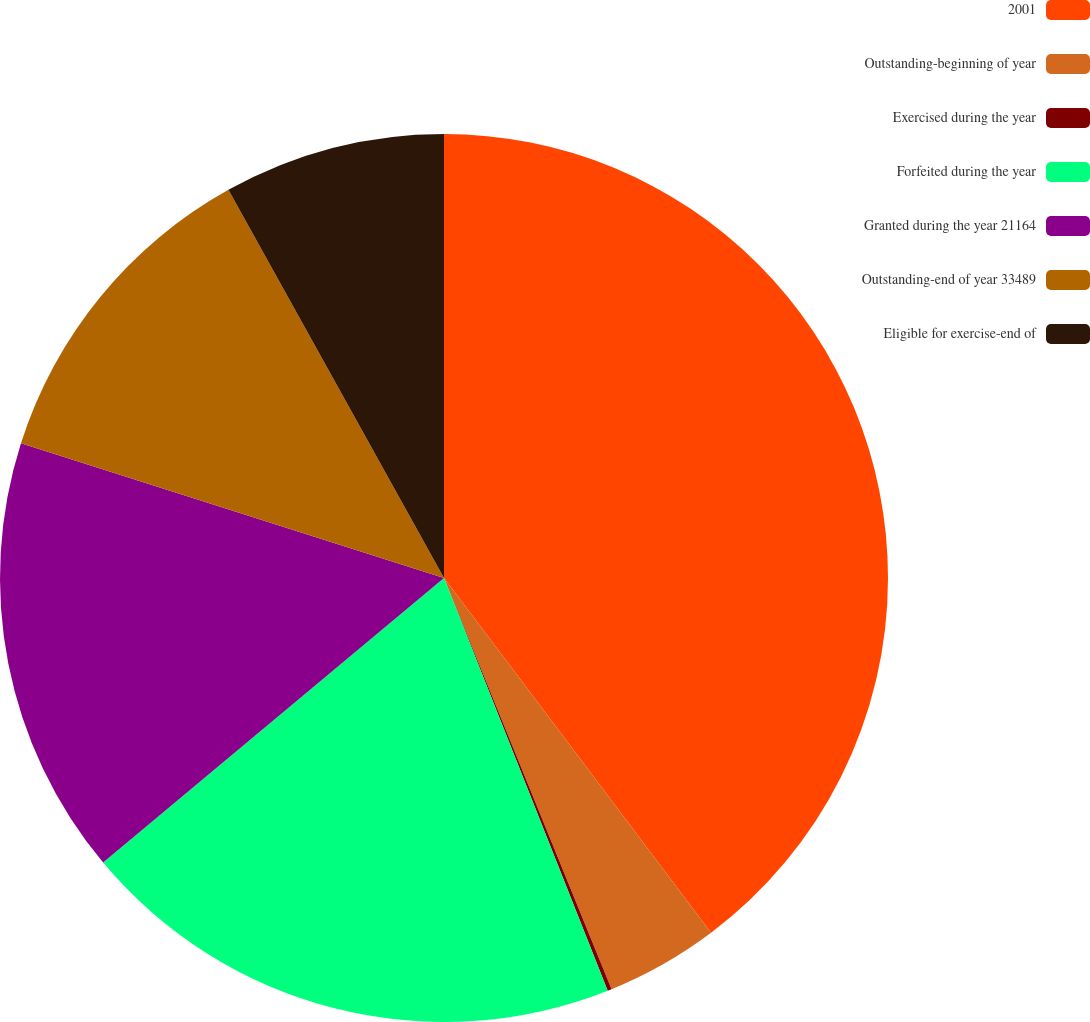<chart> <loc_0><loc_0><loc_500><loc_500><pie_chart><fcel>2001<fcel>Outstanding-beginning of year<fcel>Exercised during the year<fcel>Forfeited during the year<fcel>Granted during the year 21164<fcel>Outstanding-end of year 33489<fcel>Eligible for exercise-end of<nl><fcel>39.73%<fcel>4.11%<fcel>0.15%<fcel>19.94%<fcel>15.98%<fcel>12.02%<fcel>8.07%<nl></chart> 